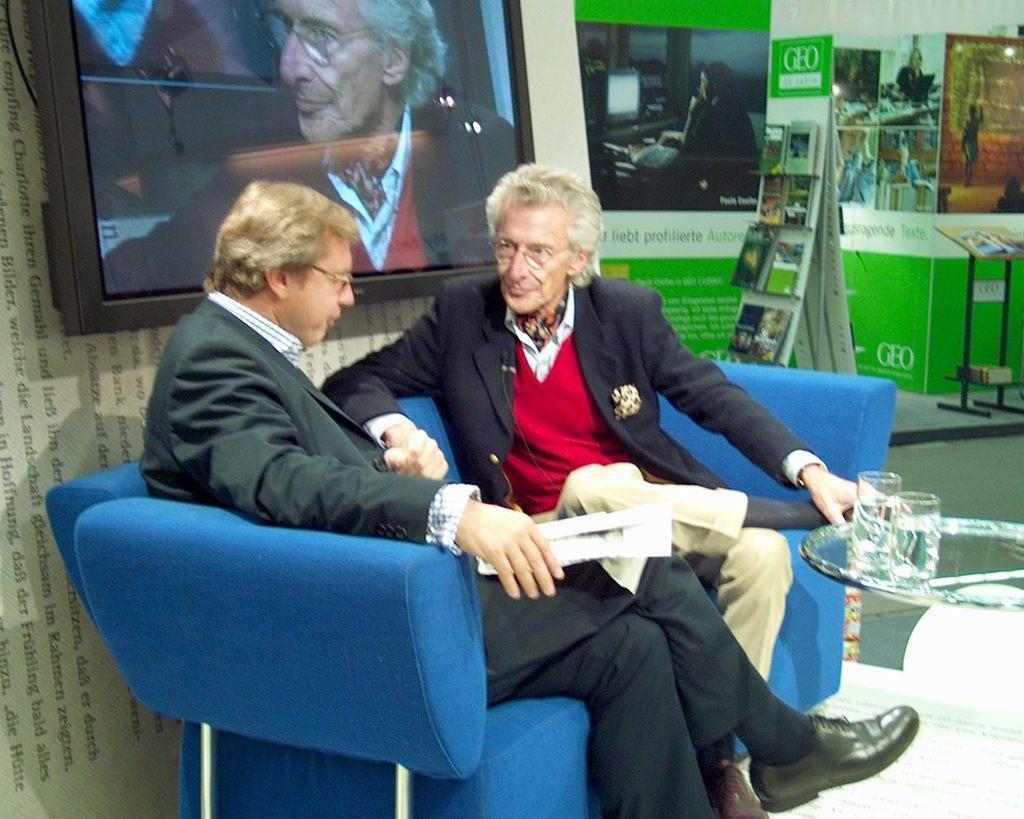In one or two sentences, can you explain what this image depicts? In this picture we can see a television, glasses, paper and two men wore spectacles, blazers and sitting on a sofa and in the background we can see books, table, posters and some objects. 